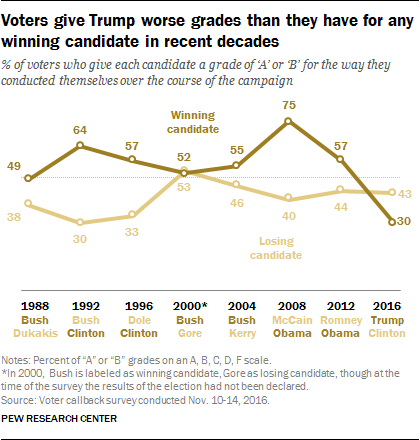List a handful of essential elements in this visual. The average grade for the winning candidate is 0.5488. In 2008, Barack Obama reached the peak of his popularity during his presidency. 